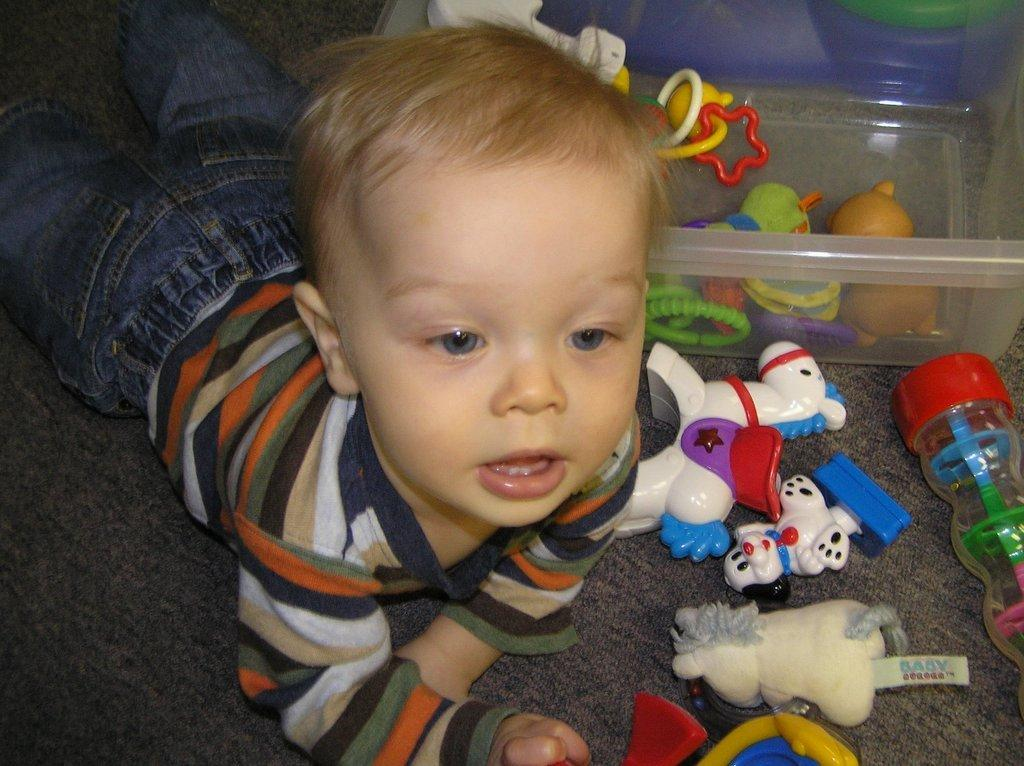What is the position of the kid in the image? The kid is lying on the floor in the image. What can be seen around the kid in the image? There are toys visible in the image. What type of container is present in the image? There is a white color plastic box in the image. What type of jam is being spread on the kid's face in the image? There is no jam present in the image, and the kid's face is not being spread with any jam. 